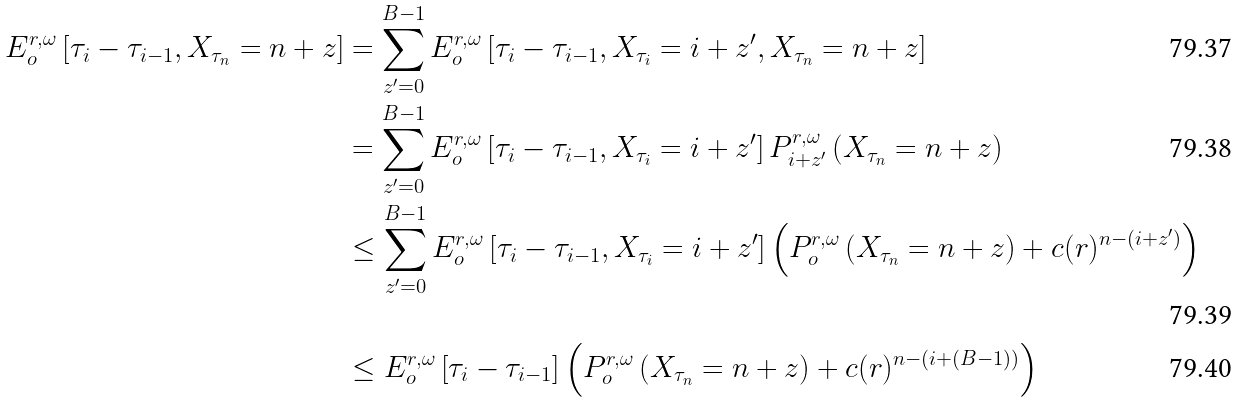<formula> <loc_0><loc_0><loc_500><loc_500>E _ { o } ^ { r , \omega } \left [ \tau _ { i } - \tau _ { i - 1 } , X _ { \tau _ { n } } = n + z \right ] & = \sum _ { z ^ { \prime } = 0 } ^ { B - 1 } E _ { o } ^ { r , \omega } \left [ \tau _ { i } - \tau _ { i - 1 } , X _ { \tau _ { i } } = i + z ^ { \prime } , X _ { \tau _ { n } } = n + z \right ] \\ & = \sum _ { z ^ { \prime } = 0 } ^ { B - 1 } E _ { o } ^ { r , \omega } \left [ \tau _ { i } - \tau _ { i - 1 } , X _ { \tau _ { i } } = i + z ^ { \prime } \right ] P _ { i + z ^ { \prime } } ^ { r , \omega } \left ( X _ { \tau _ { n } } = n + z \right ) \\ & \leq \sum _ { z ^ { \prime } = 0 } ^ { B - 1 } E _ { o } ^ { r , \omega } \left [ \tau _ { i } - \tau _ { i - 1 } , X _ { \tau _ { i } } = i + z ^ { \prime } \right ] \left ( P _ { o } ^ { r , \omega } \left ( X _ { \tau _ { n } } = n + z \right ) + c ( r ) ^ { n - ( i + z ^ { \prime } ) } \right ) \\ & \leq E _ { o } ^ { r , \omega } \left [ \tau _ { i } - \tau _ { i - 1 } \right ] \left ( P _ { o } ^ { r , \omega } \left ( X _ { \tau _ { n } } = n + z \right ) + c ( r ) ^ { n - ( i + ( B - 1 ) ) } \right )</formula> 